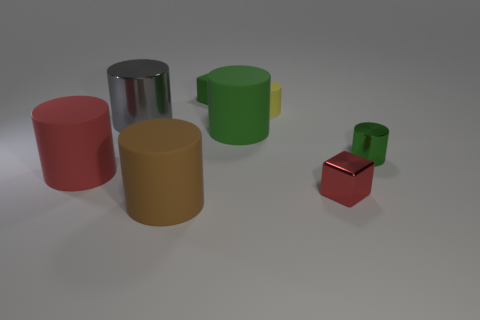Subtract all small yellow cylinders. How many cylinders are left? 5 Subtract all red cylinders. How many cylinders are left? 5 Subtract all green cylinders. Subtract all cyan cubes. How many cylinders are left? 4 Add 2 red cylinders. How many objects exist? 10 Subtract all cylinders. How many objects are left? 2 Add 4 green metallic spheres. How many green metallic spheres exist? 4 Subtract 0 blue cylinders. How many objects are left? 8 Subtract all yellow rubber things. Subtract all green rubber objects. How many objects are left? 5 Add 2 red blocks. How many red blocks are left? 3 